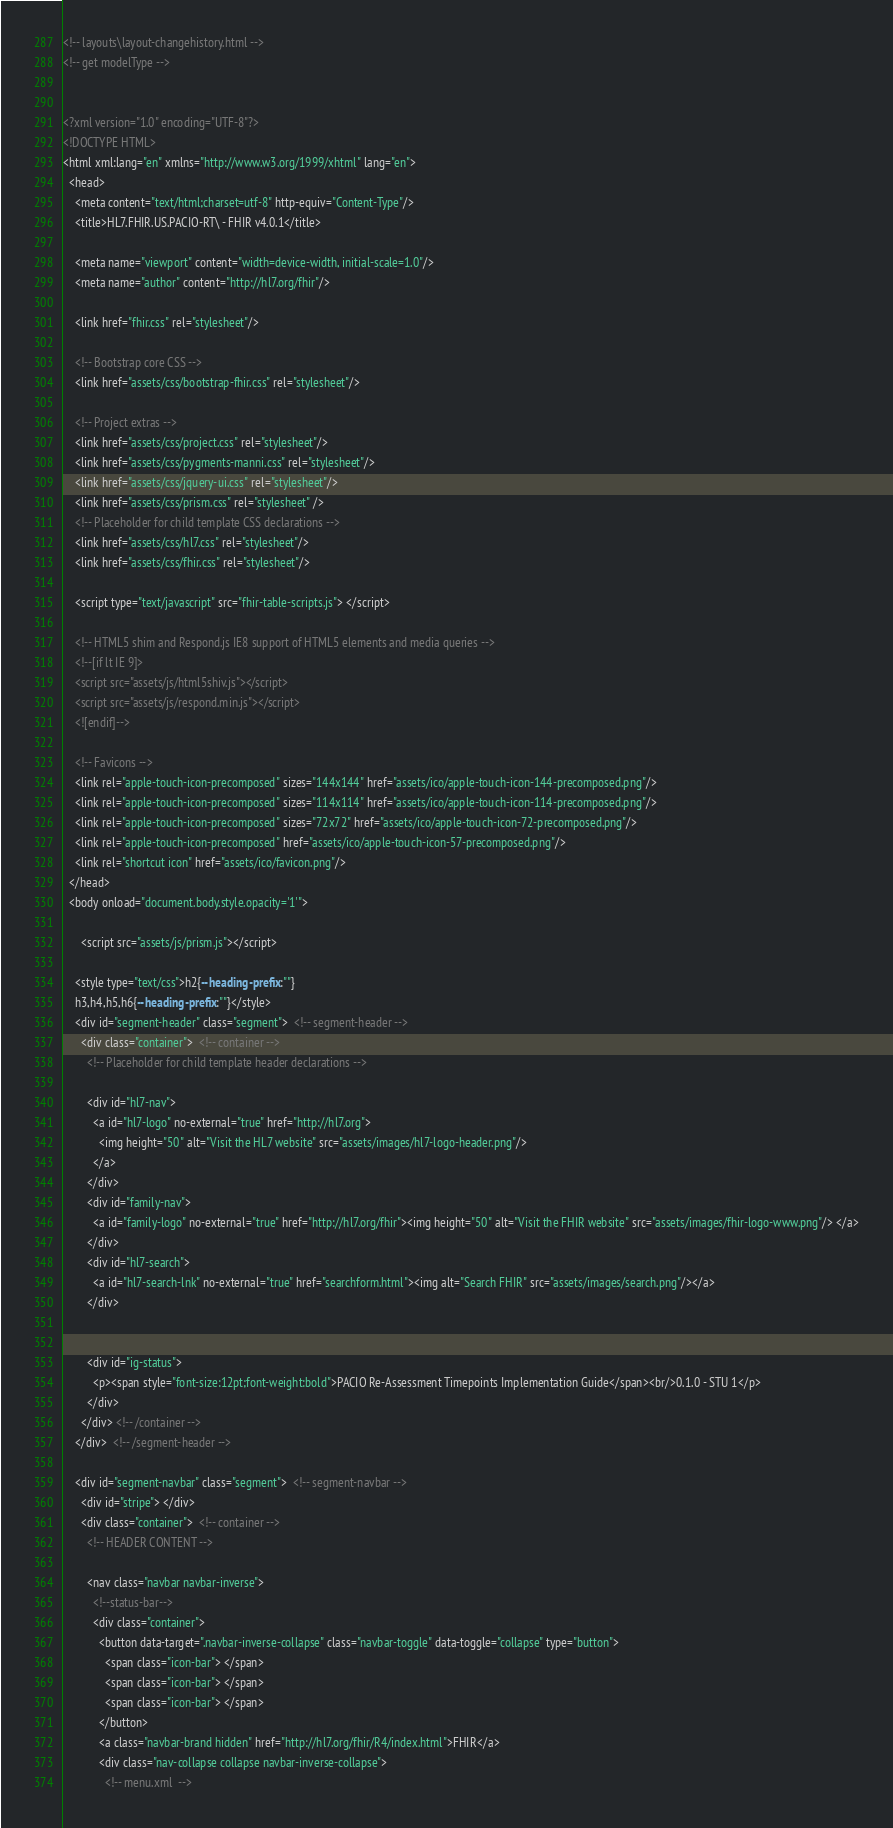Convert code to text. <code><loc_0><loc_0><loc_500><loc_500><_HTML_><!-- layouts\layout-changehistory.html -->
<!-- get modelType -->


<?xml version="1.0" encoding="UTF-8"?>
<!DOCTYPE HTML>
<html xml:lang="en" xmlns="http://www.w3.org/1999/xhtml" lang="en">
  <head>
    <meta content="text/html;charset=utf-8" http-equiv="Content-Type"/>
    <title>HL7.FHIR.US.PACIO-RT\ - FHIR v4.0.1</title>

    <meta name="viewport" content="width=device-width, initial-scale=1.0"/>
    <meta name="author" content="http://hl7.org/fhir"/>

    <link href="fhir.css" rel="stylesheet"/>

    <!-- Bootstrap core CSS -->
    <link href="assets/css/bootstrap-fhir.css" rel="stylesheet"/>

    <!-- Project extras -->
    <link href="assets/css/project.css" rel="stylesheet"/>
    <link href="assets/css/pygments-manni.css" rel="stylesheet"/>
    <link href="assets/css/jquery-ui.css" rel="stylesheet"/>
  	<link href="assets/css/prism.css" rel="stylesheet" />
    <!-- Placeholder for child template CSS declarations -->
    <link href="assets/css/hl7.css" rel="stylesheet"/>
    <link href="assets/css/fhir.css" rel="stylesheet"/>

    <script type="text/javascript" src="fhir-table-scripts.js"> </script>

    <!-- HTML5 shim and Respond.js IE8 support of HTML5 elements and media queries -->
    <!--[if lt IE 9]>
    <script src="assets/js/html5shiv.js"></script>
    <script src="assets/js/respond.min.js"></script>
    <![endif]-->

    <!-- Favicons -->
    <link rel="apple-touch-icon-precomposed" sizes="144x144" href="assets/ico/apple-touch-icon-144-precomposed.png"/>
    <link rel="apple-touch-icon-precomposed" sizes="114x114" href="assets/ico/apple-touch-icon-114-precomposed.png"/>
    <link rel="apple-touch-icon-precomposed" sizes="72x72" href="assets/ico/apple-touch-icon-72-precomposed.png"/>
    <link rel="apple-touch-icon-precomposed" href="assets/ico/apple-touch-icon-57-precomposed.png"/>
    <link rel="shortcut icon" href="assets/ico/favicon.png"/>
  </head>
  <body onload="document.body.style.opacity='1'">

	  <script src="assets/js/prism.js"></script>

    <style type="text/css">h2{--heading-prefix:""}
    h3,h4,h5,h6{--heading-prefix:""}</style>
    <div id="segment-header" class="segment">  <!-- segment-header -->
      <div class="container">  <!-- container -->
        <!-- Placeholder for child template header declarations -->

        <div id="hl7-nav">
          <a id="hl7-logo" no-external="true" href="http://hl7.org">
            <img height="50" alt="Visit the HL7 website" src="assets/images/hl7-logo-header.png"/>
          </a>
        </div>
        <div id="family-nav">
          <a id="family-logo" no-external="true" href="http://hl7.org/fhir"><img height="50" alt="Visit the FHIR website" src="assets/images/fhir-logo-www.png"/> </a>
        </div>
        <div id="hl7-search">
          <a id="hl7-search-lnk" no-external="true" href="searchform.html"><img alt="Search FHIR" src="assets/images/search.png"/></a>
        </div>


        <div id="ig-status">
          <p><span style="font-size:12pt;font-weight:bold">PACIO Re-Assessment Timepoints Implementation Guide</span><br/>0.1.0 - STU 1</p>
        </div>
      </div> <!-- /container -->
    </div>  <!-- /segment-header -->

    <div id="segment-navbar" class="segment">  <!-- segment-navbar -->
      <div id="stripe"> </div>
      <div class="container">  <!-- container -->
        <!-- HEADER CONTENT -->

        <nav class="navbar navbar-inverse">
          <!--status-bar-->
          <div class="container">
            <button data-target=".navbar-inverse-collapse" class="navbar-toggle" data-toggle="collapse" type="button">
              <span class="icon-bar"> </span>
              <span class="icon-bar"> </span>
              <span class="icon-bar"> </span>
            </button>
            <a class="navbar-brand hidden" href="http://hl7.org/fhir/R4/index.html">FHIR</a>
            <div class="nav-collapse collapse navbar-inverse-collapse">
              <!-- menu.xml  -->
</code> 